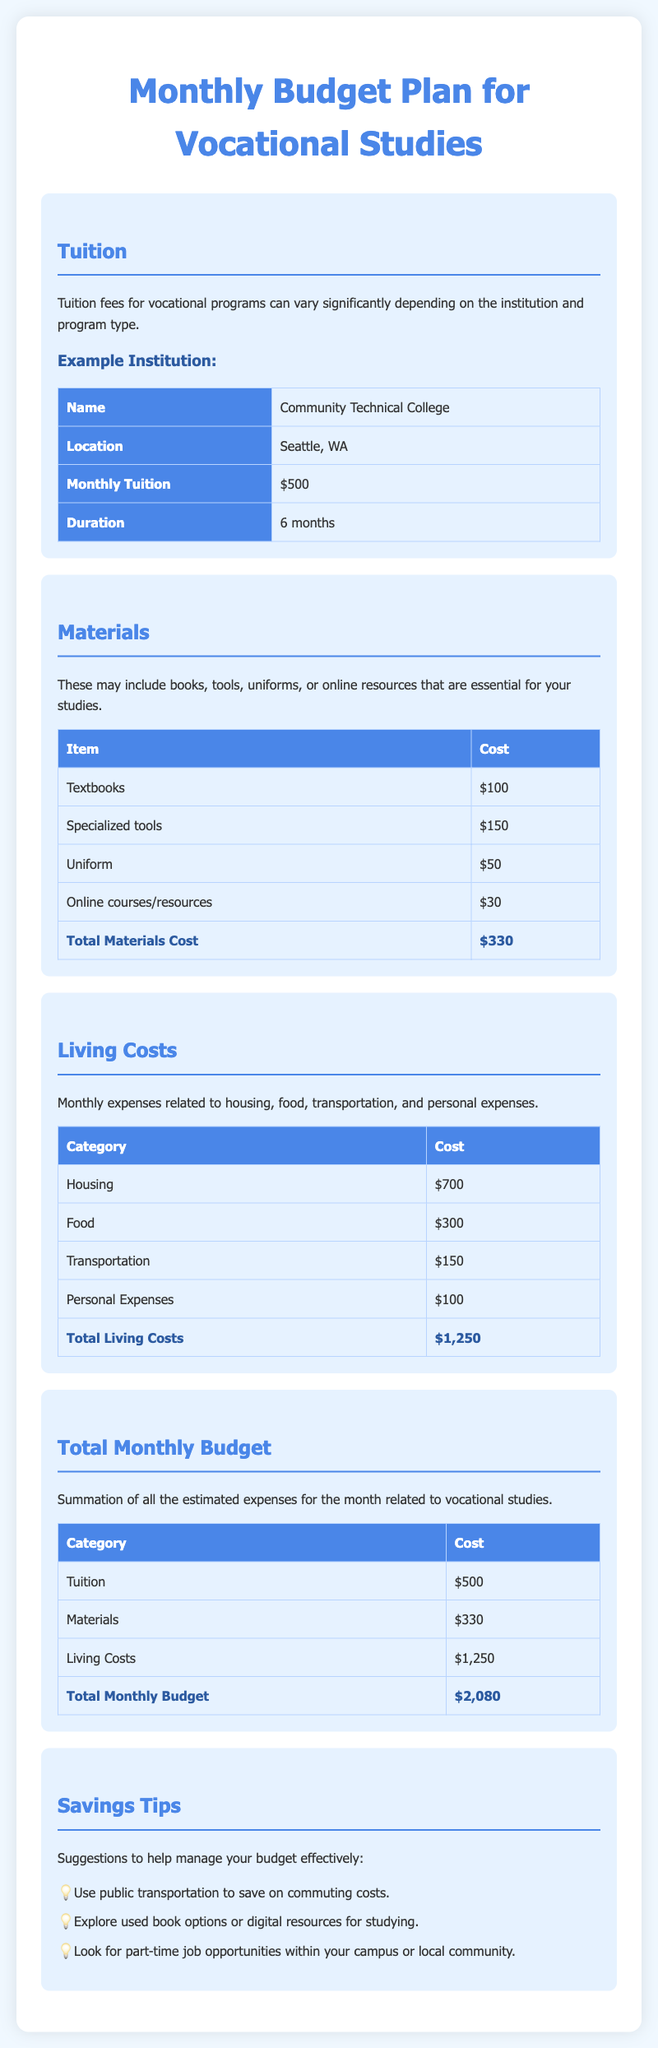What is the monthly tuition cost? The document states that the monthly tuition cost at the example institution is $500.
Answer: $500 What is the total materials cost? The total materials cost is calculated by summing all material expenses in the table, which equals $330.
Answer: $330 How much are living costs per month? The total living costs per month, as provided in the document, amount to $1,250.
Answer: $1,250 What is the total monthly budget for vocational studies? The total monthly budget is found by adding tuition, materials, and living costs, resulting in $2,080.
Answer: $2,080 What institution is used as an example? The example institution mentioned in the document is Community Technical College.
Answer: Community Technical College What is one tip for saving money given in the document? The document provides several tips, one being to use public transportation to save on commuting costs.
Answer: Use public transportation How long is the duration of the tuition payments? The duration for the tuition payments mentioned is 6 months.
Answer: 6 months What is the cost of specialized tools? The document lists the cost of specialized tools as $150.
Answer: $150 How much is allocated for food expenses? The monthly food expenses are stated as $300 in the living costs section.
Answer: $300 